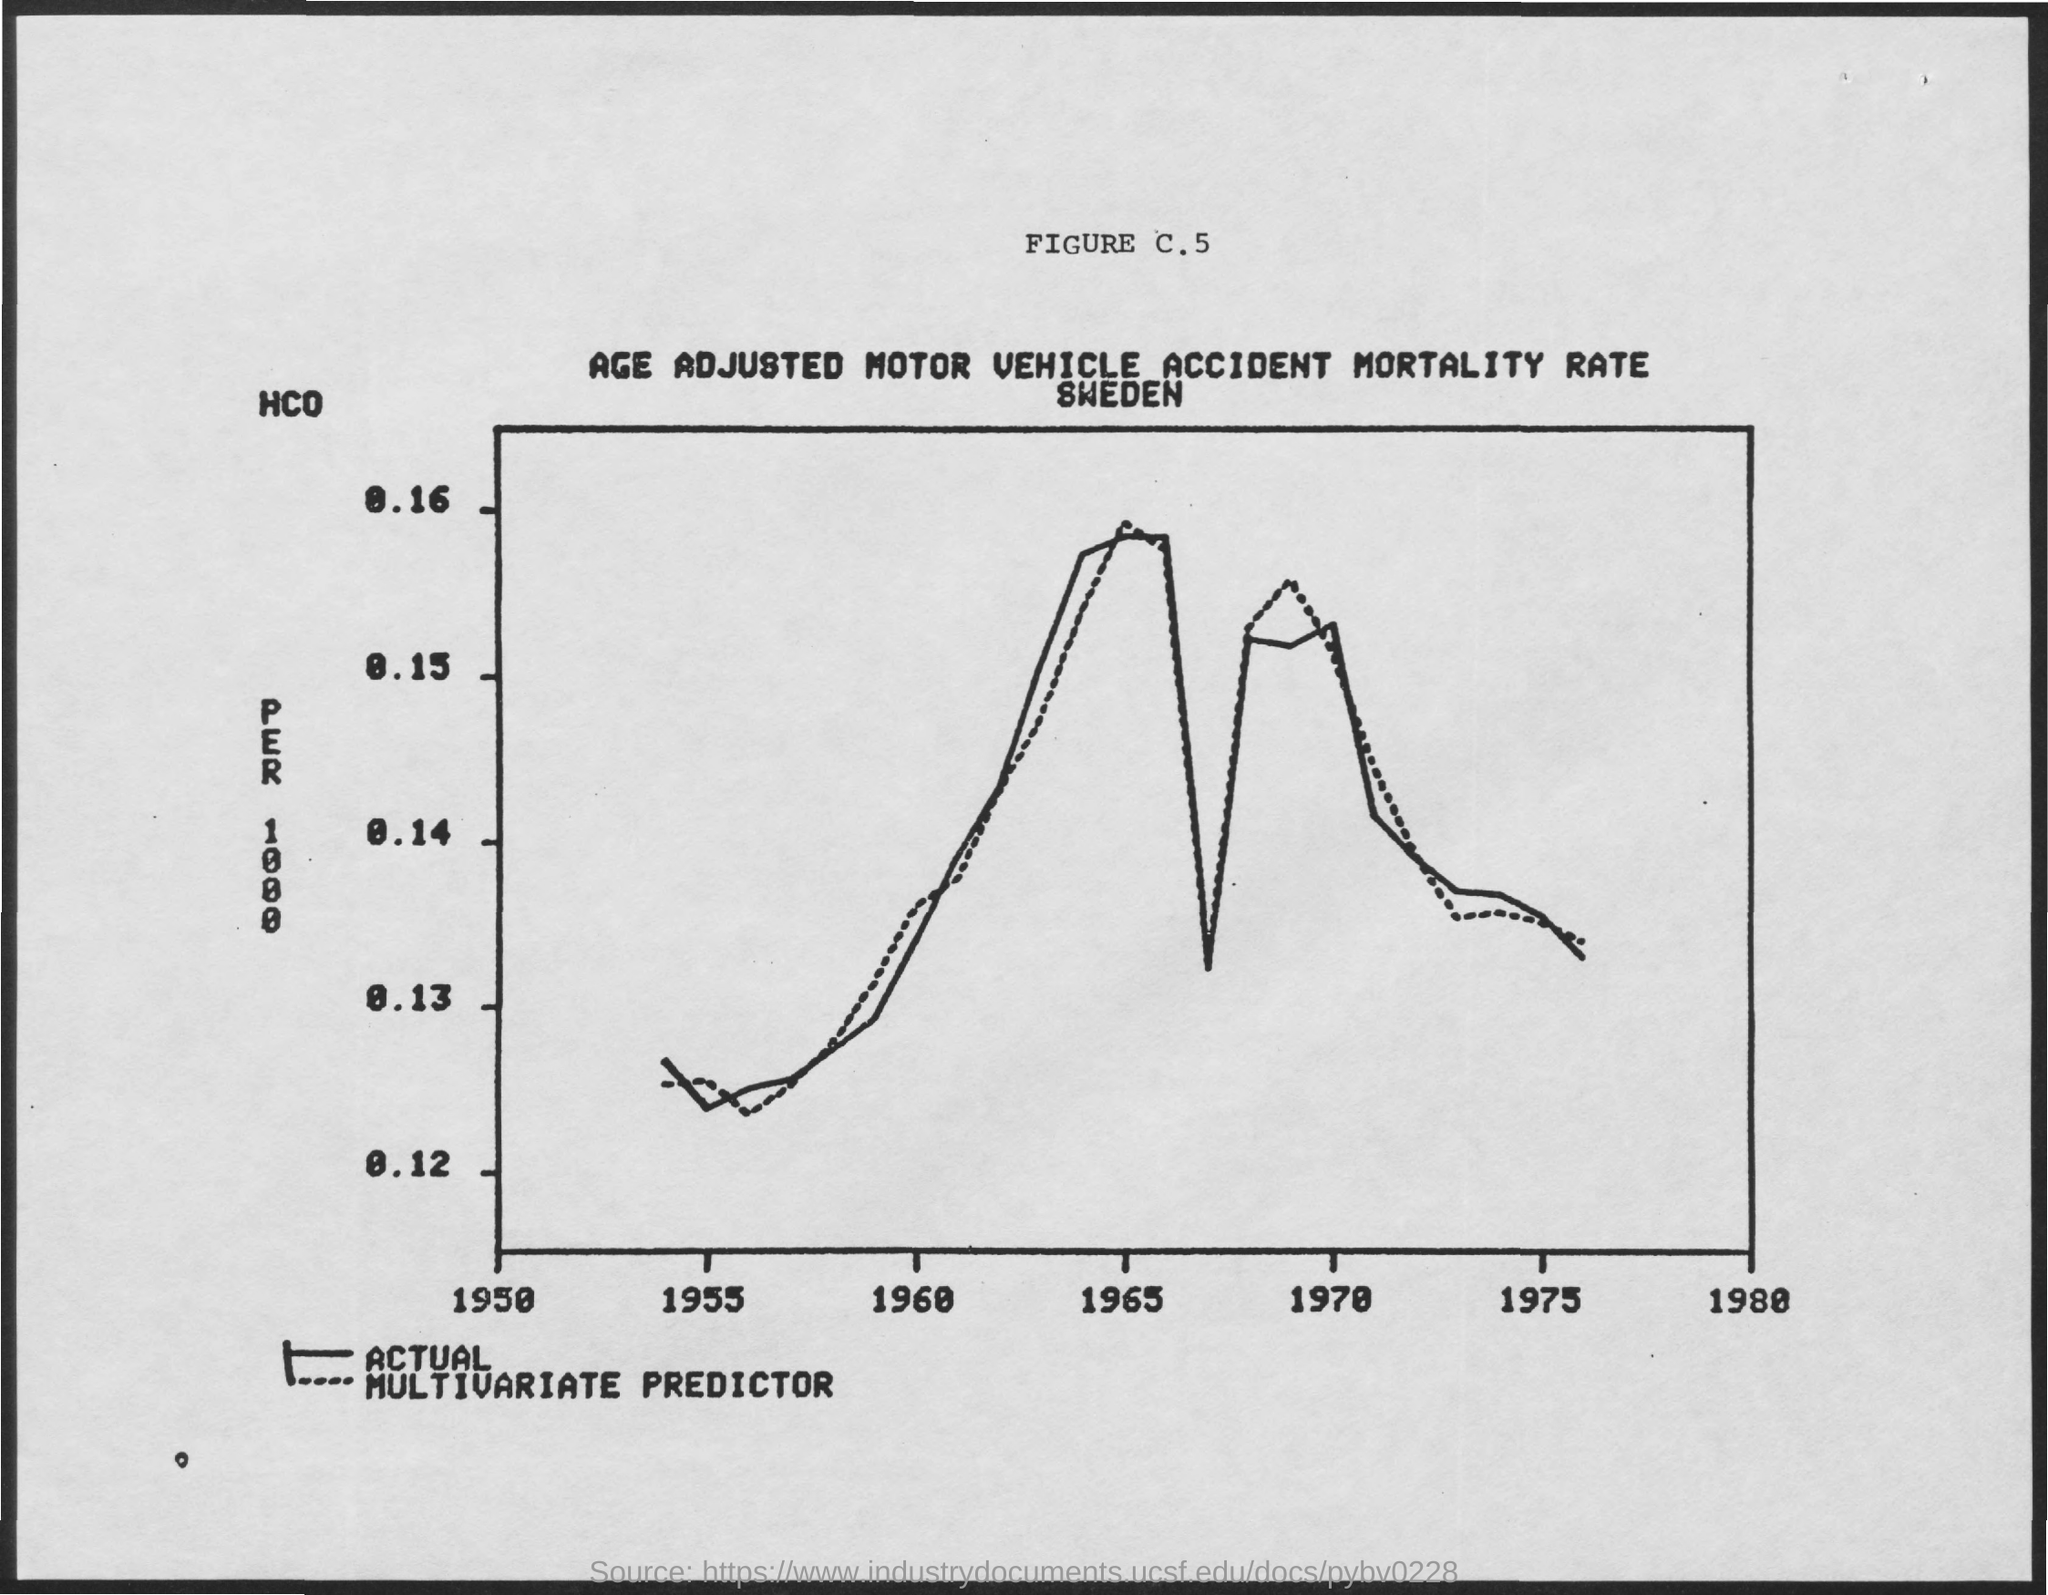List a handful of essential elements in this visual. The year 1980 is mentioned last on the x-axis. 